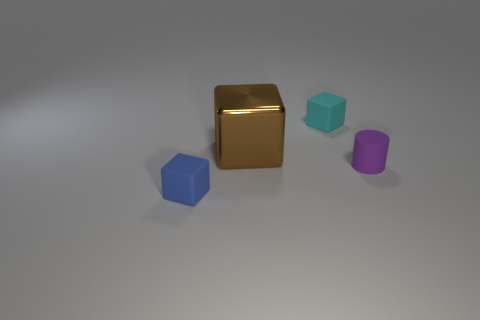How many brown things are behind the rubber cube in front of the brown shiny cube?
Give a very brief answer. 1. Do the cube in front of the purple rubber thing and the small block that is behind the tiny blue block have the same material?
Provide a succinct answer. Yes. What number of other things have the same shape as the small cyan rubber thing?
Provide a short and direct response. 2. Do the cyan cube and the big brown block that is behind the blue block have the same material?
Your response must be concise. No. There is a purple cylinder that is the same size as the blue rubber object; what is it made of?
Your answer should be very brief. Rubber. Is there another purple rubber cylinder of the same size as the cylinder?
Provide a succinct answer. No. There is a cyan matte object that is the same size as the purple matte cylinder; what is its shape?
Offer a very short reply. Cube. How many other objects are there of the same color as the small cylinder?
Offer a terse response. 0. What shape is the small matte thing that is in front of the big brown block and on the left side of the purple matte object?
Offer a very short reply. Cube. Are there any small blue cubes that are behind the rubber block on the right side of the blue object on the left side of the purple cylinder?
Your answer should be compact. No. 